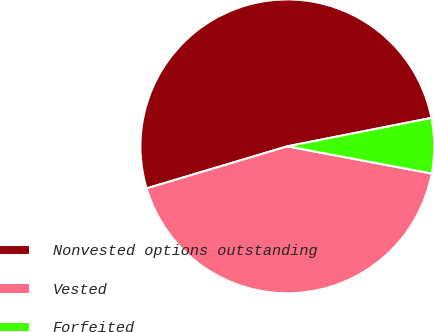Convert chart to OTSL. <chart><loc_0><loc_0><loc_500><loc_500><pie_chart><fcel>Nonvested options outstanding<fcel>Vested<fcel>Forfeited<nl><fcel>51.52%<fcel>42.42%<fcel>6.06%<nl></chart> 